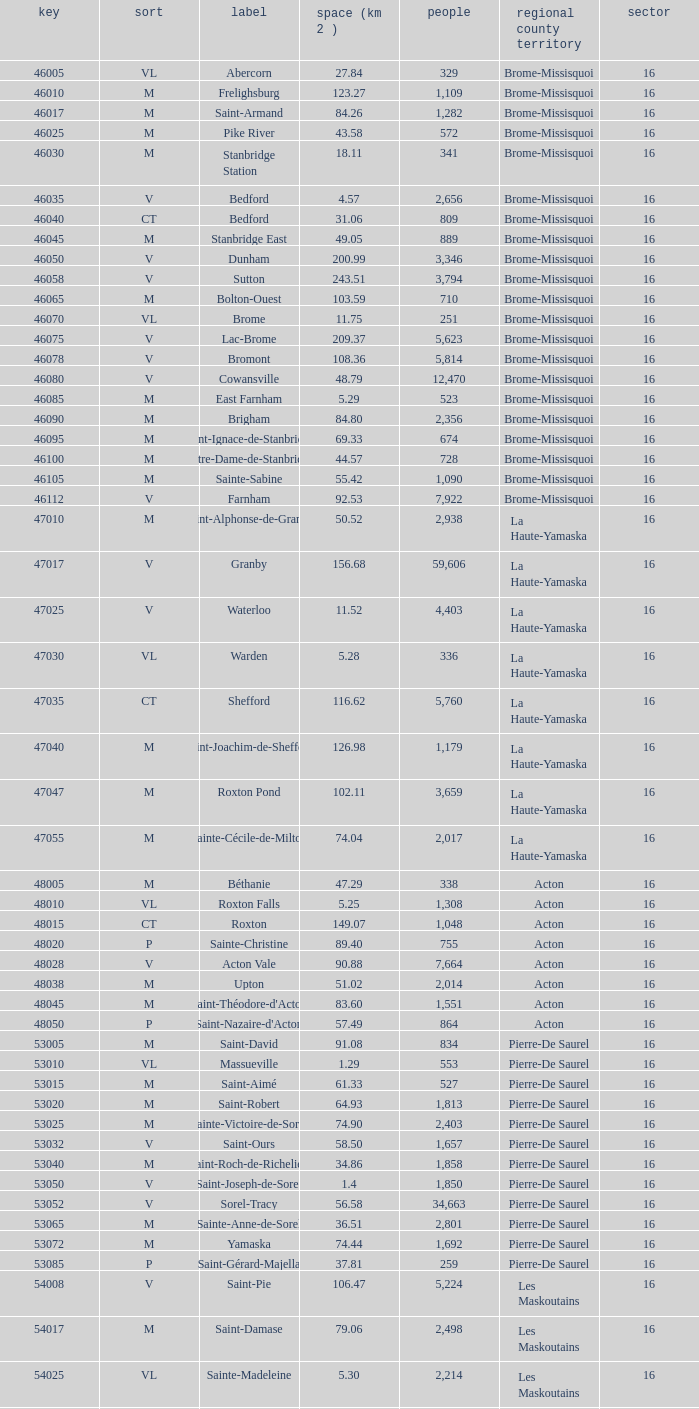Cowansville has less than 16 regions and is a Brome-Missisquoi Municipality, what is their population? None. Write the full table. {'header': ['key', 'sort', 'label', 'space (km 2 )', 'people', 'regional county territory', 'sector'], 'rows': [['46005', 'VL', 'Abercorn', '27.84', '329', 'Brome-Missisquoi', '16'], ['46010', 'M', 'Frelighsburg', '123.27', '1,109', 'Brome-Missisquoi', '16'], ['46017', 'M', 'Saint-Armand', '84.26', '1,282', 'Brome-Missisquoi', '16'], ['46025', 'M', 'Pike River', '43.58', '572', 'Brome-Missisquoi', '16'], ['46030', 'M', 'Stanbridge Station', '18.11', '341', 'Brome-Missisquoi', '16'], ['46035', 'V', 'Bedford', '4.57', '2,656', 'Brome-Missisquoi', '16'], ['46040', 'CT', 'Bedford', '31.06', '809', 'Brome-Missisquoi', '16'], ['46045', 'M', 'Stanbridge East', '49.05', '889', 'Brome-Missisquoi', '16'], ['46050', 'V', 'Dunham', '200.99', '3,346', 'Brome-Missisquoi', '16'], ['46058', 'V', 'Sutton', '243.51', '3,794', 'Brome-Missisquoi', '16'], ['46065', 'M', 'Bolton-Ouest', '103.59', '710', 'Brome-Missisquoi', '16'], ['46070', 'VL', 'Brome', '11.75', '251', 'Brome-Missisquoi', '16'], ['46075', 'V', 'Lac-Brome', '209.37', '5,623', 'Brome-Missisquoi', '16'], ['46078', 'V', 'Bromont', '108.36', '5,814', 'Brome-Missisquoi', '16'], ['46080', 'V', 'Cowansville', '48.79', '12,470', 'Brome-Missisquoi', '16'], ['46085', 'M', 'East Farnham', '5.29', '523', 'Brome-Missisquoi', '16'], ['46090', 'M', 'Brigham', '84.80', '2,356', 'Brome-Missisquoi', '16'], ['46095', 'M', 'Saint-Ignace-de-Stanbridge', '69.33', '674', 'Brome-Missisquoi', '16'], ['46100', 'M', 'Notre-Dame-de-Stanbridge', '44.57', '728', 'Brome-Missisquoi', '16'], ['46105', 'M', 'Sainte-Sabine', '55.42', '1,090', 'Brome-Missisquoi', '16'], ['46112', 'V', 'Farnham', '92.53', '7,922', 'Brome-Missisquoi', '16'], ['47010', 'M', 'Saint-Alphonse-de-Granby', '50.52', '2,938', 'La Haute-Yamaska', '16'], ['47017', 'V', 'Granby', '156.68', '59,606', 'La Haute-Yamaska', '16'], ['47025', 'V', 'Waterloo', '11.52', '4,403', 'La Haute-Yamaska', '16'], ['47030', 'VL', 'Warden', '5.28', '336', 'La Haute-Yamaska', '16'], ['47035', 'CT', 'Shefford', '116.62', '5,760', 'La Haute-Yamaska', '16'], ['47040', 'M', 'Saint-Joachim-de-Shefford', '126.98', '1,179', 'La Haute-Yamaska', '16'], ['47047', 'M', 'Roxton Pond', '102.11', '3,659', 'La Haute-Yamaska', '16'], ['47055', 'M', 'Sainte-Cécile-de-Milton', '74.04', '2,017', 'La Haute-Yamaska', '16'], ['48005', 'M', 'Béthanie', '47.29', '338', 'Acton', '16'], ['48010', 'VL', 'Roxton Falls', '5.25', '1,308', 'Acton', '16'], ['48015', 'CT', 'Roxton', '149.07', '1,048', 'Acton', '16'], ['48020', 'P', 'Sainte-Christine', '89.40', '755', 'Acton', '16'], ['48028', 'V', 'Acton Vale', '90.88', '7,664', 'Acton', '16'], ['48038', 'M', 'Upton', '51.02', '2,014', 'Acton', '16'], ['48045', 'M', "Saint-Théodore-d'Acton", '83.60', '1,551', 'Acton', '16'], ['48050', 'P', "Saint-Nazaire-d'Acton", '57.49', '864', 'Acton', '16'], ['53005', 'M', 'Saint-David', '91.08', '834', 'Pierre-De Saurel', '16'], ['53010', 'VL', 'Massueville', '1.29', '553', 'Pierre-De Saurel', '16'], ['53015', 'M', 'Saint-Aimé', '61.33', '527', 'Pierre-De Saurel', '16'], ['53020', 'M', 'Saint-Robert', '64.93', '1,813', 'Pierre-De Saurel', '16'], ['53025', 'M', 'Sainte-Victoire-de-Sorel', '74.90', '2,403', 'Pierre-De Saurel', '16'], ['53032', 'V', 'Saint-Ours', '58.50', '1,657', 'Pierre-De Saurel', '16'], ['53040', 'M', 'Saint-Roch-de-Richelieu', '34.86', '1,858', 'Pierre-De Saurel', '16'], ['53050', 'V', 'Saint-Joseph-de-Sorel', '1.4', '1,850', 'Pierre-De Saurel', '16'], ['53052', 'V', 'Sorel-Tracy', '56.58', '34,663', 'Pierre-De Saurel', '16'], ['53065', 'M', 'Sainte-Anne-de-Sorel', '36.51', '2,801', 'Pierre-De Saurel', '16'], ['53072', 'M', 'Yamaska', '74.44', '1,692', 'Pierre-De Saurel', '16'], ['53085', 'P', 'Saint-Gérard-Majella', '37.81', '259', 'Pierre-De Saurel', '16'], ['54008', 'V', 'Saint-Pie', '106.47', '5,224', 'Les Maskoutains', '16'], ['54017', 'M', 'Saint-Damase', '79.06', '2,498', 'Les Maskoutains', '16'], ['54025', 'VL', 'Sainte-Madeleine', '5.30', '2,214', 'Les Maskoutains', '16'], ['54030', 'P', 'Sainte-Marie-Madeleine', '49.53', '2,713', 'Les Maskoutains', '16'], ['54035', 'M', 'La Présentation', '104.71', '2,078', 'Les Maskoutains', '16'], ['54048', 'V', 'Saint-Hyacinthe', '189.11', '51,984', 'Les Maskoutains', '16'], ['54060', 'M', 'Saint-Dominique', '70.16', '2,308', 'Les Maskoutains', '16'], ['54065', 'M', 'Saint-Valérien-de-Milton', '106.44', '1,785', 'Les Maskoutains', '16'], ['54072', 'M', 'Saint-Liboire', '72.90', '2,846', 'Les Maskoutains', '16'], ['54090', 'M', 'Saint-Simon', '68.66', '1,136', 'Les Maskoutains', '16'], ['54095', 'M', 'Sainte-Hélène-de-Bagot', '73.53', '1,541', 'Les Maskoutains', '16'], ['54100', 'M', 'Saint-Hugues', '89.30', '1,420', 'Les Maskoutains', '16'], ['54105', 'M', 'Saint-Barnabé-Sud', '57.08', '881', 'Les Maskoutains', '16'], ['54110', 'M', 'Saint-Jude', '77.36', '1,111', 'Les Maskoutains', '16'], ['54115', 'M', 'Saint-Bernard-de-Michaudville', '64.80', '581', 'Les Maskoutains', '16'], ['54120', 'M', 'Saint-Louis', '45.92', '752', 'Les Maskoutains', '16'], ['54125', 'M', 'Saint-Marcel-de-Richelieu', '50.21', '613', 'Les Maskoutains', '16'], ['55008', 'M', 'Ange-Gardien', '89.07', '1,994', 'Rouville', '16'], ['55015', 'M', "Saint-Paul-d'Abbotsford", '79.59', '2,910', 'Rouville', '16'], ['55023', 'V', 'Saint-Césaire', '84.14', '5,039', 'Rouville', '16'], ['55030', 'M', 'Sainte-Angèle-de-Monnoir', '45.49', '1,474', 'Rouville', '16'], ['55037', 'M', 'Rougemont', '44.48', '2,631', 'Rouville', '16'], ['55048', 'V', 'Marieville', '64.25', '7,377', 'Rouville', '16'], ['55057', 'V', 'Richelieu', '29.75', '5,658', 'Rouville', '16'], ['55065', 'M', 'Saint-Mathias-sur-Richelieu', '48.22', '4,453', 'Rouville', '16'], ['56005', 'M', 'Venise-en-Québec', '13.57', '1,414', 'Le Haut-Richelieu', '16'], ['56010', 'M', 'Saint-Georges-de-Clarenceville', '63.76', '1,170', 'Le Haut-Richelieu', '16'], ['56015', 'M', 'Noyan', '43.79', '1,192', 'Le Haut-Richelieu', '16'], ['56023', 'M', 'Lacolle', '49.17', '2,502', 'Le Haut-Richelieu', '16'], ['56030', 'M', 'Saint-Valentin', '40.09', '527', 'Le Haut-Richelieu', '16'], ['56035', 'M', "Saint-Paul-de-l'Île-aux-Noix", '29.47', '2,049', 'Le Haut-Richelieu', '16'], ['56042', 'M', 'Henryville', '64.87', '1,520', 'Le Haut-Richelieu', '16'], ['56050', 'M', 'Saint-Sébastien', '62.65', '759', 'Le Haut-Richelieu', '16'], ['56055', 'M', 'Saint-Alexandre', '76.55', '2,517', 'Le Haut-Richelieu', '16'], ['56060', 'P', 'Sainte-Anne-de-Sabrevois', '45.24', '1,964', 'Le Haut-Richelieu', '16'], ['56065', 'M', 'Saint-Blaise-sur-Richelieu', '68.42', '2,040', 'Le Haut-Richelieu', '16'], ['56083', 'V', 'Saint-Jean-sur-Richelieu', '225.61', '86,802', 'Le Haut-Richelieu', '16'], ['56097', 'M', 'Mont-Saint-Grégoire', '79.92', '3,077', 'Le Haut-Richelieu', '16'], ['56105', 'M', "Sainte-Brigide-d'Iberville", '68.89', '1,260', 'Le Haut-Richelieu', '16'], ['57005', 'V', 'Chambly', '25.01', '22,332', 'La Vallée-du-Richelieu', '16'], ['57010', 'V', 'Carignan', '62.39', '6,911', 'La Vallée-du-Richelieu', '16'], ['57020', 'V', 'Saint-Basile-le-Grand', '34.82', '15,100', 'La Vallée-du-Richelieu', '16'], ['57025', 'M', 'McMasterville', '3.00', '4,773', 'La Vallée-du-Richelieu', '16'], ['57030', 'V', 'Otterburn Park', '5.20', '8,696', 'La Vallée-du-Richelieu', '16'], ['57033', 'M', 'Saint-Jean-Baptiste', '75.98', '2,875', 'La Vallée-du-Richelieu', '16'], ['57035', 'V', 'Mont-Saint-Hilaire', '38.96', '15,820', 'La Vallée-du-Richelieu', '16'], ['57040', 'V', 'Beloeil', '24.00', '19,428', 'La Vallée-du-Richelieu', '16'], ['57045', 'M', 'Saint-Mathieu-de-Beloeil', '39.26', '2,381', 'La Vallée-du-Richelieu', '16'], ['57050', 'M', 'Saint-Marc-sur-Richelieu', '59.51', '1,992', 'La Vallée-du-Richelieu', '16'], ['57057', 'M', 'Saint-Charles-sur-Richelieu', '63.59', '1,808', 'La Vallée-du-Richelieu', '16'], ['57068', 'M', 'Saint-Denis-sur-Richelieu', '82.20', '2,272', 'La Vallée-du-Richelieu', '16'], ['57075', 'M', 'Saint-Antoine-sur-Richelieu', '65.26', '1,571', 'La Vallée-du-Richelieu', '16'], ['58007', 'V', 'Brossard', '44.77', '71,372', 'Not part of a RCM', '16'], ['58012', 'V', 'Saint-Lambert', '6.43', '21,772', 'Not part of a RCM', '16'], ['58033', 'V', 'Boucherville', '69.33', '38,526', 'Not part of a RCM', '16'], ['58037', 'V', 'Saint-Bruno-de-Montarville', '41.89', '24,571', 'Not part of a RCM', '16'], ['58227', 'V', 'Longueuil', '111.50', '231,969', 'Not part of a RCM', '16'], ['59010', 'V', 'Sainte-Julie', '47.78', '29,000', "Marguerite-D'Youville", '16'], ['59015', 'M', 'Saint-Amable', '38.04', '8,135', "Marguerite-D'Youville", '16'], ['59020', 'V', 'Varennes', '93.96', '20,608', "Marguerite-D'Youville", '16'], ['59025', 'M', 'Verchères', '72.77', '5,103', "Marguerite-D'Youville", '16'], ['59030', 'P', 'Calixa-Lavallée', '32.42', '517', "Marguerite-D'Youville", '16'], ['59035', 'V', 'Contrecœur', '61.56', '5,603', "Marguerite-D'Youville", '16'], ['67005', 'M', 'Saint-Mathieu', '32.27', '2,032', 'Roussillon', '16'], ['67010', 'M', 'Saint-Philippe', '61.66', '4,763', 'Roussillon', '16'], ['67015', 'V', 'La Prairie', '43.53', '21,609', 'Roussillon', '16'], ['67020', 'V', 'Candiac', '16.40', '14,866', 'Roussillon', '16'], ['67025', 'V', 'Delson', '7.76', '7,382', 'Roussillon', '16'], ['67030', 'V', 'Sainte-Catherine', '9.06', '16,770', 'Roussillon', '16'], ['67035', 'V', 'Saint-Constant', '56.58', '24,679', 'Roussillon', '16'], ['67040', 'P', 'Saint-Isidore', '52.00', '2,476', 'Roussillon', '16'], ['67045', 'V', 'Mercier', '45.89', '10,231', 'Roussillon', '16'], ['67050', 'V', 'Châteauguay', '35.37', '43,178', 'Roussillon', '16'], ['67055', 'V', 'Léry', '10.98', '2,368', 'Roussillon', '16'], ['68005', 'P', 'Saint-Bernard-de-Lacolle', '112.63', '1,601', 'Les Jardins-de-Napierville', '16'], ['68010', 'VL', 'Hemmingford', '0.85', '737', 'Les Jardins-de-Napierville', '16'], ['68015', 'CT', 'Hemmingford', '155.78', '1,735', 'Les Jardins-de-Napierville', '16'], ['68020', 'M', 'Sainte-Clotilde', '78.96', '1,593', 'Les Jardins-de-Napierville', '16'], ['68025', 'M', 'Saint-Patrice-de-Sherrington', '91.47', '1,946', 'Les Jardins-de-Napierville', '16'], ['68030', 'M', 'Napierville', '4.53', '3,310', 'Les Jardins-de-Napierville', '16'], ['68035', 'M', 'Saint-Cyprien-de-Napierville', '97.62', '1,414', 'Les Jardins-de-Napierville', '16'], ['68040', 'M', 'Saint-Jacques-le-Mineur', '65.19', '1,670', 'Les Jardins-de-Napierville', '16'], ['68045', 'M', 'Saint-Édouard', '52.91', '1,226', 'Les Jardins-de-Napierville', '16'], ['68050', 'M', 'Saint-Michel', '57.36', '2,681', 'Les Jardins-de-Napierville', '16'], ['68055', 'V', 'Saint-Rémi', '79.66', '6,089', 'Les Jardins-de-Napierville', '16'], ['69005', 'CT', 'Havelock', '87.98', '853', 'Le Haut-Saint-Laurent', '16'], ['69010', 'M', 'Franklin', '112.19', '1,601', 'Le Haut-Saint-Laurent', '16'], ['69017', 'M', 'Saint-Chrysostome', '99.54', '2,689', 'Le Haut-Saint-Laurent', '16'], ['69025', 'M', 'Howick', '0.89', '589', 'Le Haut-Saint-Laurent', '16'], ['69030', 'P', 'Très-Saint-Sacrement', '97.30', '1,250', 'Le Haut-Saint-Laurent', '16'], ['69037', 'M', 'Ormstown', '142.39', '3,742', 'Le Haut-Saint-Laurent', '16'], ['69045', 'M', 'Hinchinbrooke', '148.95', '2,425', 'Le Haut-Saint-Laurent', '16'], ['69050', 'M', 'Elgin', '69.38', '463', 'Le Haut-Saint-Laurent', '16'], ['69055', 'V', 'Huntingdon', '2.58', '2,695', 'Le Haut-Saint-Laurent', '16'], ['69060', 'CT', 'Godmanchester', '138.77', '1,512', 'Le Haut-Saint-Laurent', '16'], ['69065', 'M', 'Sainte-Barbe', '39.78', '1,407', 'Le Haut-Saint-Laurent', '16'], ['69070', 'M', 'Saint-Anicet', '136.25', '2,736', 'Le Haut-Saint-Laurent', '16'], ['69075', 'CT', 'Dundee', '94.20', '406', 'Le Haut-Saint-Laurent', '16'], ['70005', 'M', 'Saint-Urbain-Premier', '52.24', '1,181', 'Beauharnois-Salaberry', '16'], ['70012', 'M', 'Sainte-Martine', '59.79', '4,037', 'Beauharnois-Salaberry', '16'], ['70022', 'V', 'Beauharnois', '73.05', '12,041', 'Beauharnois-Salaberry', '16'], ['70030', 'M', 'Saint-Étienne-de-Beauharnois', '41.62', '738', 'Beauharnois-Salaberry', '16'], ['70035', 'P', 'Saint-Louis-de-Gonzague', '78.52', '1,402', 'Beauharnois-Salaberry', '16'], ['70040', 'M', 'Saint-Stanislas-de-Kostka', '62.16', '1,653', 'Beauharnois-Salaberry', '16'], ['70052', 'V', 'Salaberry-de-Valleyfield', '100.96', '40,056', 'Beauharnois-Salaberry', '16'], ['71005', 'M', 'Rivière-Beaudette', '19.62', '1,701', 'Vaudreuil-Soulanges', '16'], ['71015', 'M', 'Saint-Télesphore', '59.62', '777', 'Vaudreuil-Soulanges', '16'], ['71020', 'M', 'Saint-Polycarpe', '70.80', '1,737', 'Vaudreuil-Soulanges', '16'], ['71025', 'M', 'Saint-Zotique', '24.24', '4,947', 'Vaudreuil-Soulanges', '16'], ['71033', 'M', 'Les Coteaux', '12.11', '3,684', 'Vaudreuil-Soulanges', '16'], ['71040', 'V', 'Coteau-du-Lac', '46.57', '6,458', 'Vaudreuil-Soulanges', '16'], ['71045', 'M', 'Saint-Clet', '38.61', '1,663', 'Vaudreuil-Soulanges', '16'], ['71050', 'M', 'Les Cèdres', '78.31', '5,842', 'Vaudreuil-Soulanges', '16'], ['71055', 'VL', 'Pointe-des-Cascades', '2.66', '1,014', 'Vaudreuil-Soulanges', '16'], ['71060', 'V', "L'Île-Perrot", '4.86', '10,131', 'Vaudreuil-Soulanges', '16'], ['71065', 'V', "Notre-Dame-de-l'Île-Perrot", '28.14', '9,783', 'Vaudreuil-Soulanges', '16'], ['71070', 'V', 'Pincourt', '8.36', '10,960', 'Vaudreuil-Soulanges', '16'], ['71075', 'M', 'Terrasse-Vaudreuil', '1.08', '2,086', 'Vaudreuil-Soulanges', '16'], ['71083', 'V', 'Vaudreuil-Dorion', '73.18', '24,589', 'Vaudreuil-Soulanges', '16'], ['71090', 'VL', 'Vaudreuil-sur-le-Lac', '1.73', '1,058', 'Vaudreuil-Soulanges', '16'], ['71095', 'V', "L'Île-Cadieux", '0.62', '141', 'Vaudreuil-Soulanges', '16'], ['71100', 'V', 'Hudson', '21.62', '5,193', 'Vaudreuil-Soulanges', '16'], ['71105', 'V', 'Saint-Lazare', '67.59', '15,954', 'Vaudreuil-Soulanges', '16'], ['71110', 'M', 'Sainte-Marthe', '80.23', '1,142', 'Vaudreuil-Soulanges', '16'], ['71115', 'M', 'Sainte-Justine-de-Newton', '84.14', '968', 'Vaudreuil-Soulanges', '16'], ['71125', 'M', 'Très-Saint-Rédempteur', '25.40', '645', 'Vaudreuil-Soulanges', '16'], ['71133', 'M', 'Rigaud', '97.15', '6,724', 'Vaudreuil-Soulanges', '16'], ['71140', 'VL', 'Pointe-Fortune', '9.09', '512', 'Vaudreuil-Soulanges', '16']]} 